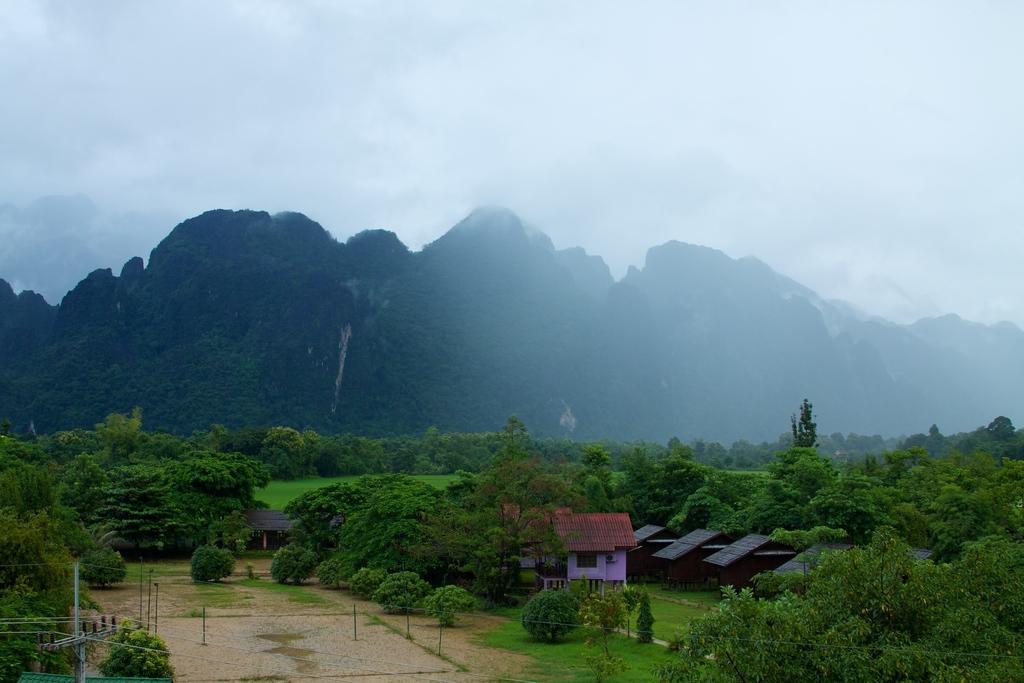Please provide a concise description of this image. In this image we can see the houses, trees, grass and also the hills. We can also see the electrical pole with the wires on the left. We can also see some rods, and sand at the top we can see the fog. 